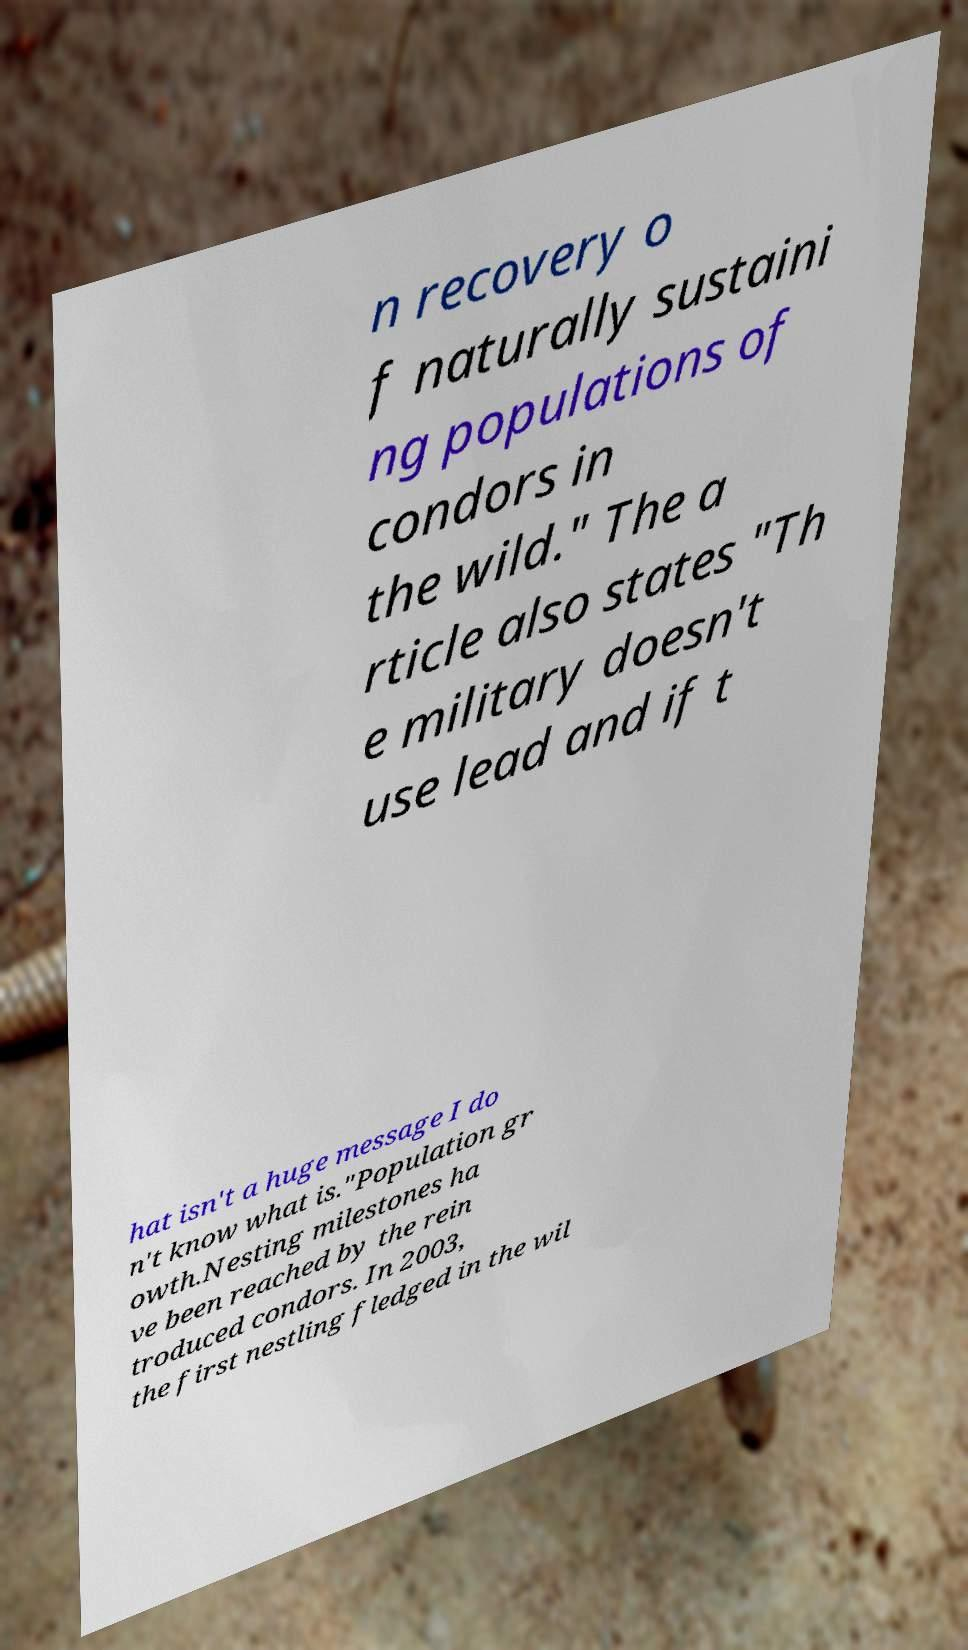Could you extract and type out the text from this image? n recovery o f naturally sustaini ng populations of condors in the wild." The a rticle also states "Th e military doesn't use lead and if t hat isn't a huge message I do n't know what is."Population gr owth.Nesting milestones ha ve been reached by the rein troduced condors. In 2003, the first nestling fledged in the wil 